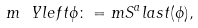<formula> <loc_0><loc_0><loc_500><loc_500>m \ Y l e f t \phi \colon = m S ^ { a } l a s t ( \phi ) ,</formula> 